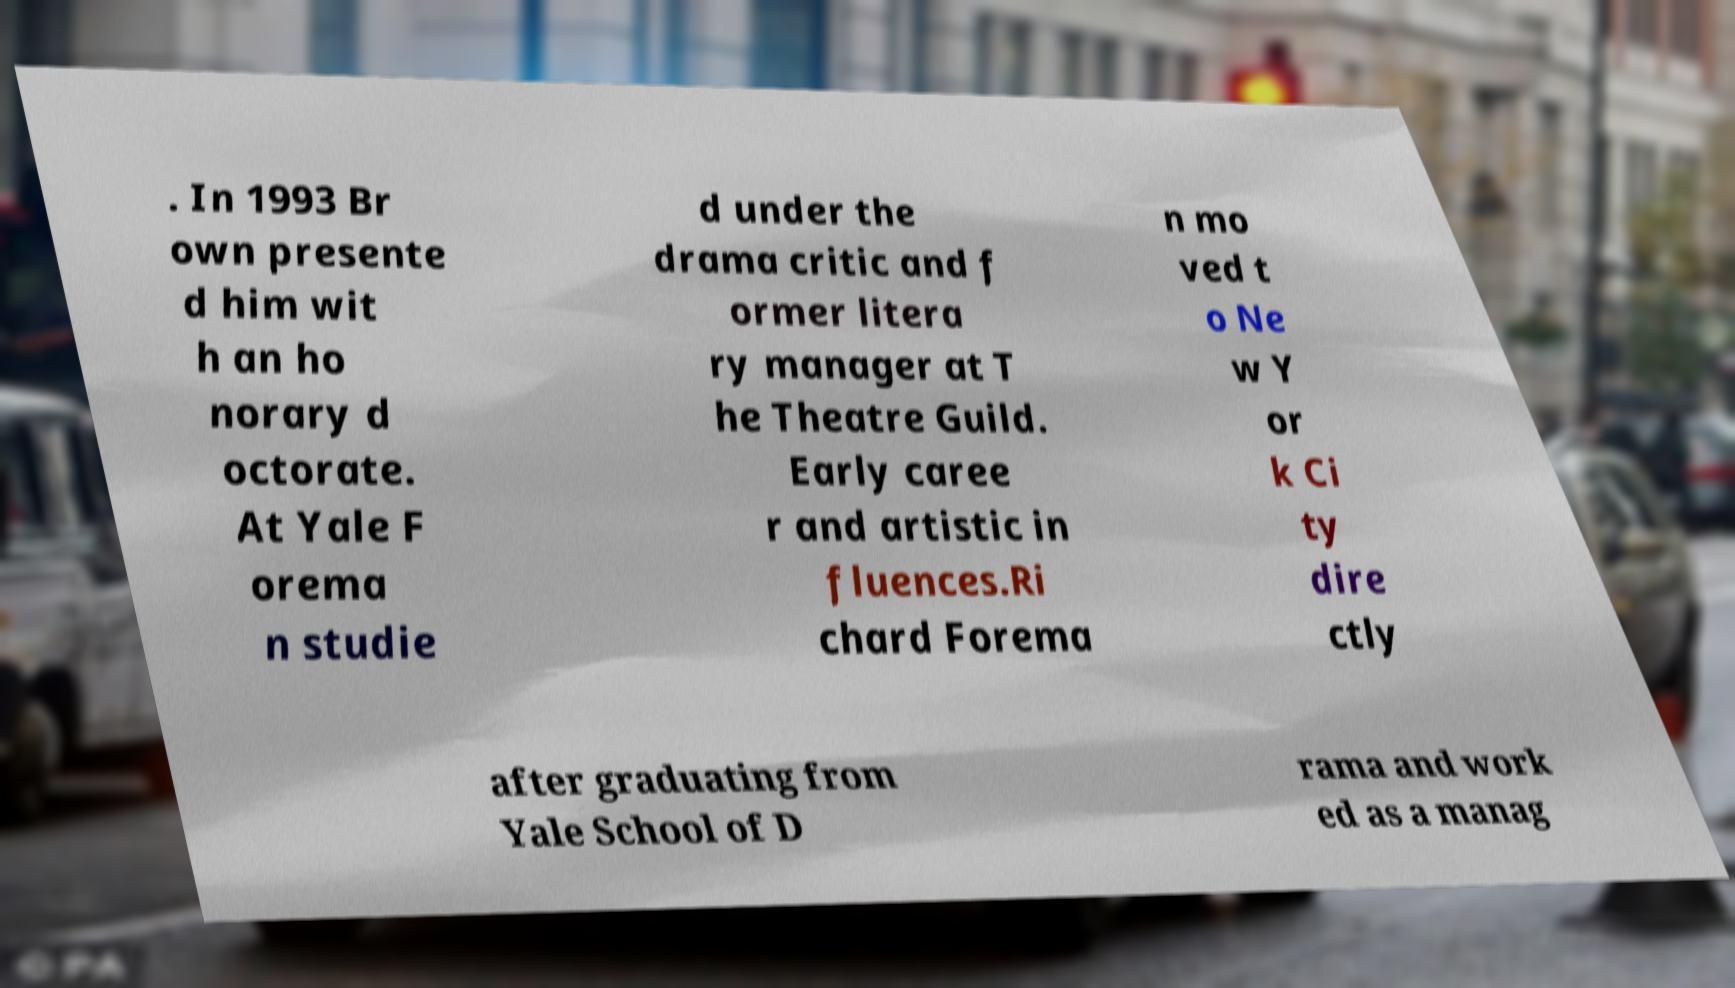Could you assist in decoding the text presented in this image and type it out clearly? . In 1993 Br own presente d him wit h an ho norary d octorate. At Yale F orema n studie d under the drama critic and f ormer litera ry manager at T he Theatre Guild. Early caree r and artistic in fluences.Ri chard Forema n mo ved t o Ne w Y or k Ci ty dire ctly after graduating from Yale School of D rama and work ed as a manag 